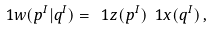Convert formula to latex. <formula><loc_0><loc_0><loc_500><loc_500>\ 1 w ( p ^ { I } | q ^ { I } ) = \ 1 z ( p ^ { I } ) \ 1 x ( q ^ { I } ) \, ,</formula> 